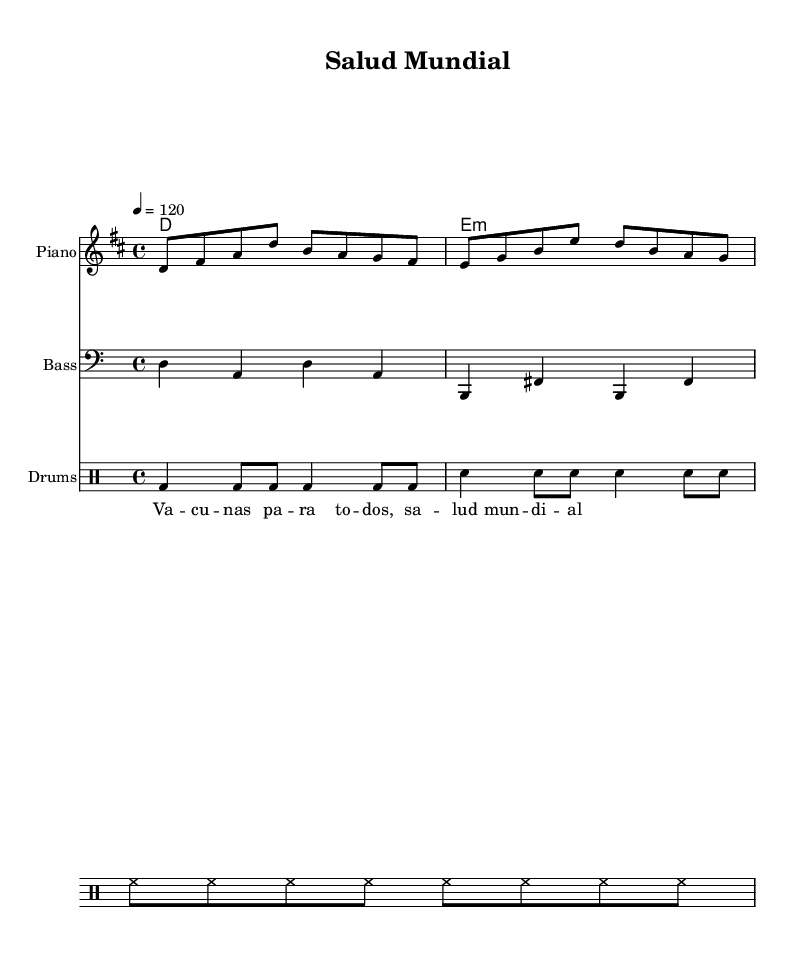What is the key signature of this music? The key signature is D major, which has two sharps (F# and C#). This can be identified from the global section where it is specified.
Answer: D major What is the time signature of this music? The time signature is 4/4, meaning there are four beats in each measure. This is clearly stated in the global section as well.
Answer: 4/4 What is the tempo marking for this piece? The tempo marking indicates a pace of 120 beats per minute. This is marked in the global section with the indication "4 = 120."
Answer: 120 How many measures are in the melody? The melody consists of 8 measures, as each line represents a measure and there are 8 measures total in the melody section.
Answer: 8 What musical form does this piece represent? The musical form can be identified as a simple verse-chorus structure, which is typical in upbeat Latin pop songs aimed at promoting global health initiatives. This can be inferred from the lyrics and the repetitive nature of the melody.
Answer: Verse-chorus What is the lyric for the first measure? The lyrics for the first measure are "Va - cu - nas pa - ra to - dos." This is present directly under the melody in the lyrics staff.
Answer: Va - cu - nas pa - ra to - dos Which instruments are involved in this score? The score includes the piano, bass, and drums. This can be seen from the respective staffs and their labels at the beginning of each section.
Answer: Piano, bass, drums 